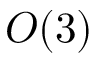Convert formula to latex. <formula><loc_0><loc_0><loc_500><loc_500>O ( 3 )</formula> 